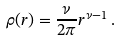<formula> <loc_0><loc_0><loc_500><loc_500>\rho ( r ) = \frac { \nu } { 2 \pi } r ^ { \nu - 1 } \, .</formula> 